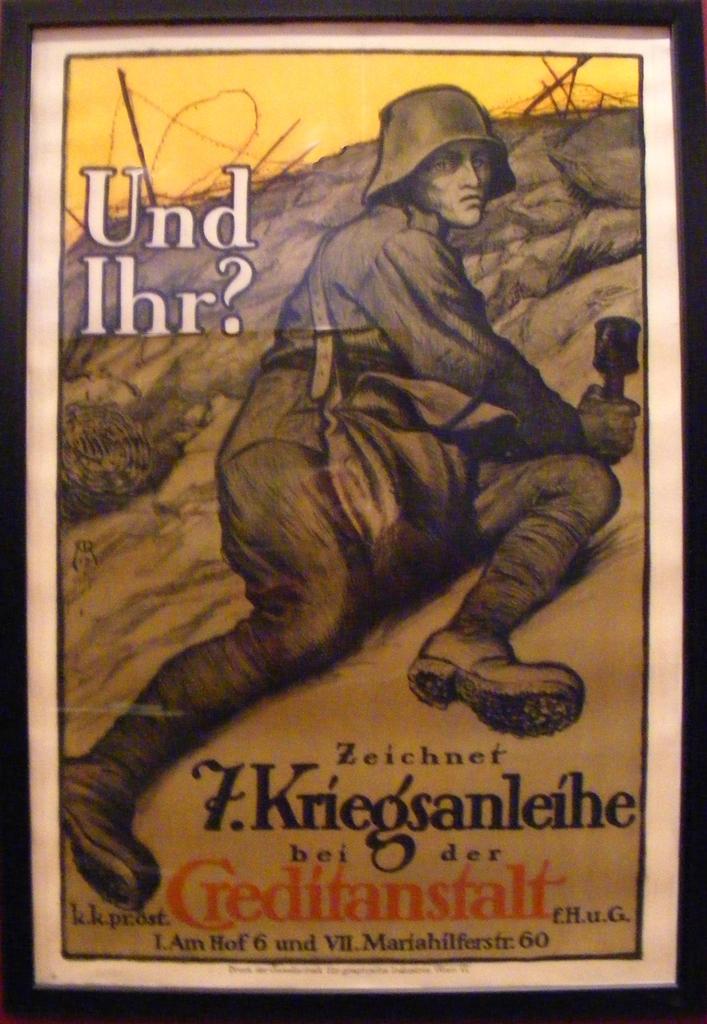What is the title of the book?
Your response must be concise. Und ihr?. 